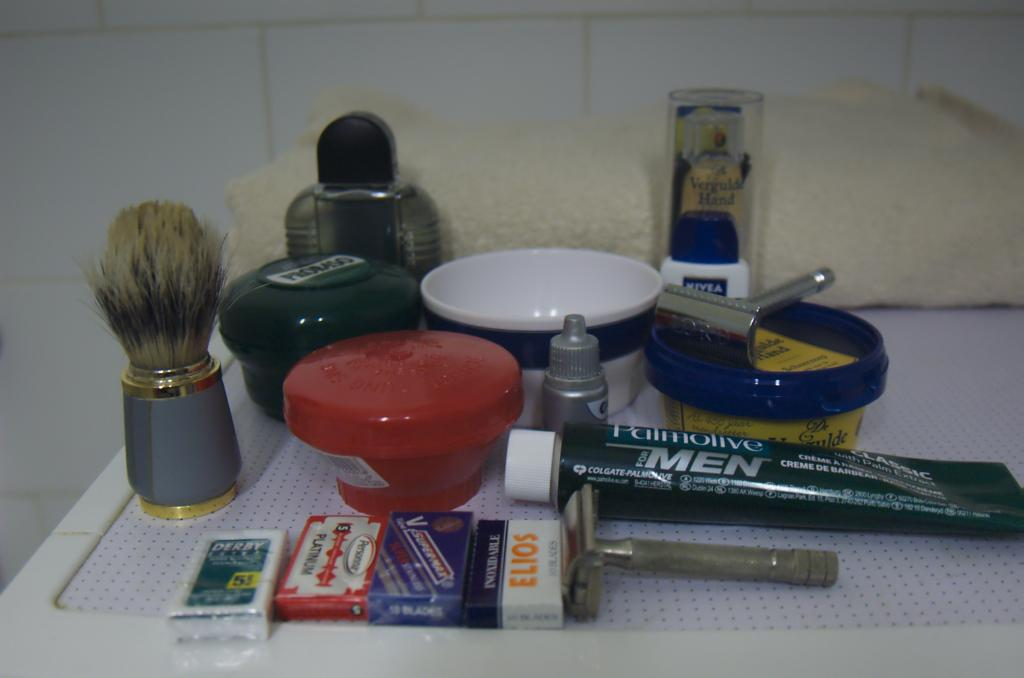<image>
Render a clear and concise summary of the photo. A tube of Palmolive for Men is placed with other shaving things. 